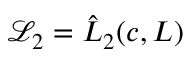<formula> <loc_0><loc_0><loc_500><loc_500>\mathcal { L } _ { 2 } = \hat { L } _ { 2 } ( c , L )</formula> 